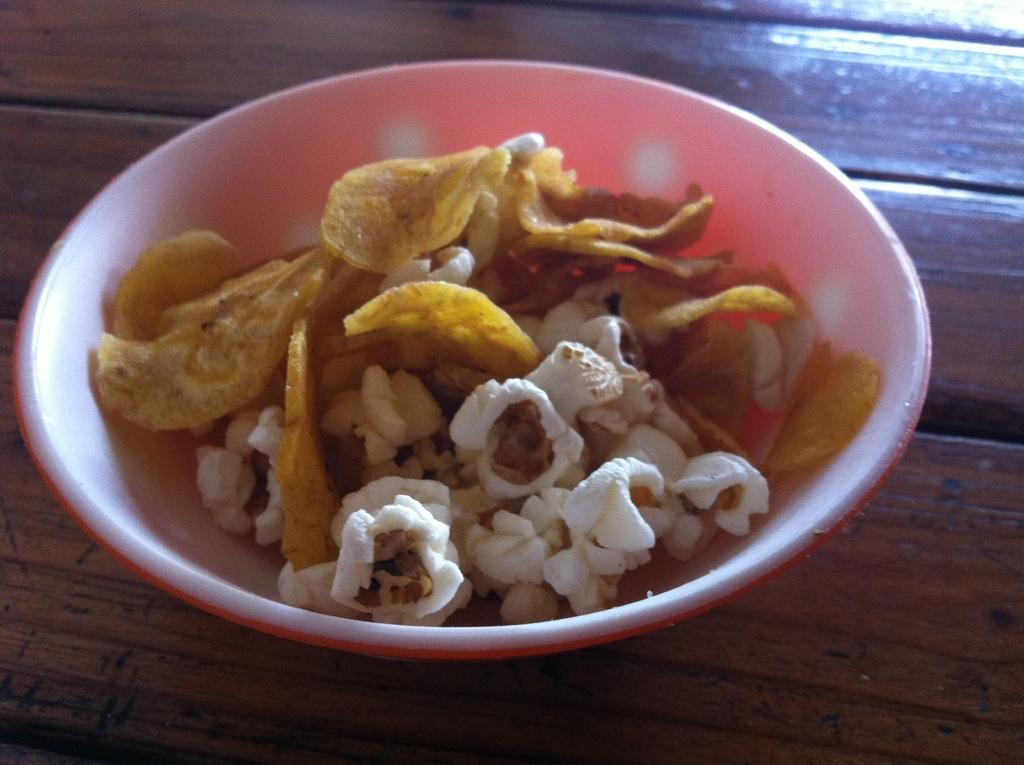What is present in the image that can hold items? There is a bowl in the image that can hold items. What type of items are in the bowl? The bowl contains food items. Where is the bowl located in the image? The bowl is placed on a platform. What type of pen can be seen writing on the bowl in the image? There is no pen present in the image, and the bowl is not being written on. 